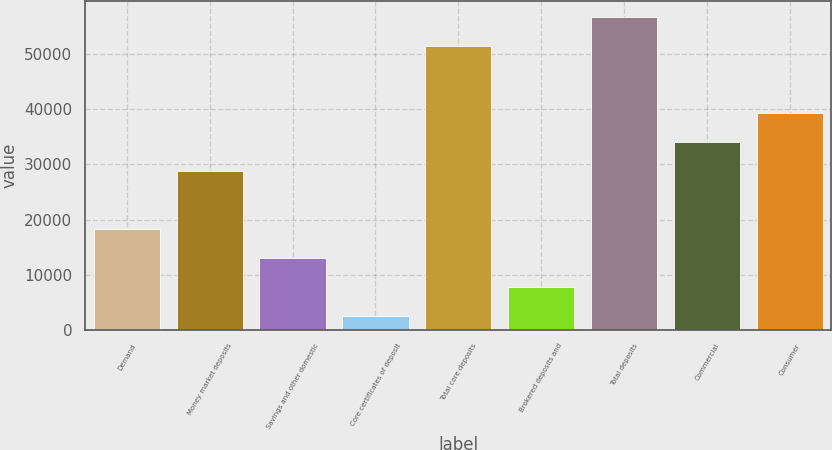Convert chart. <chart><loc_0><loc_0><loc_500><loc_500><bar_chart><fcel>Demand<fcel>Money market deposits<fcel>Savings and other domestic<fcel>Core certificates of deposit<fcel>Total core deposits<fcel>Brokered deposits and<fcel>Total deposits<fcel>Commercial<fcel>Consumer<nl><fcel>18255.9<fcel>28838.5<fcel>12964.6<fcel>2382<fcel>51582<fcel>7673.3<fcel>56873.3<fcel>34129.8<fcel>39421.1<nl></chart> 